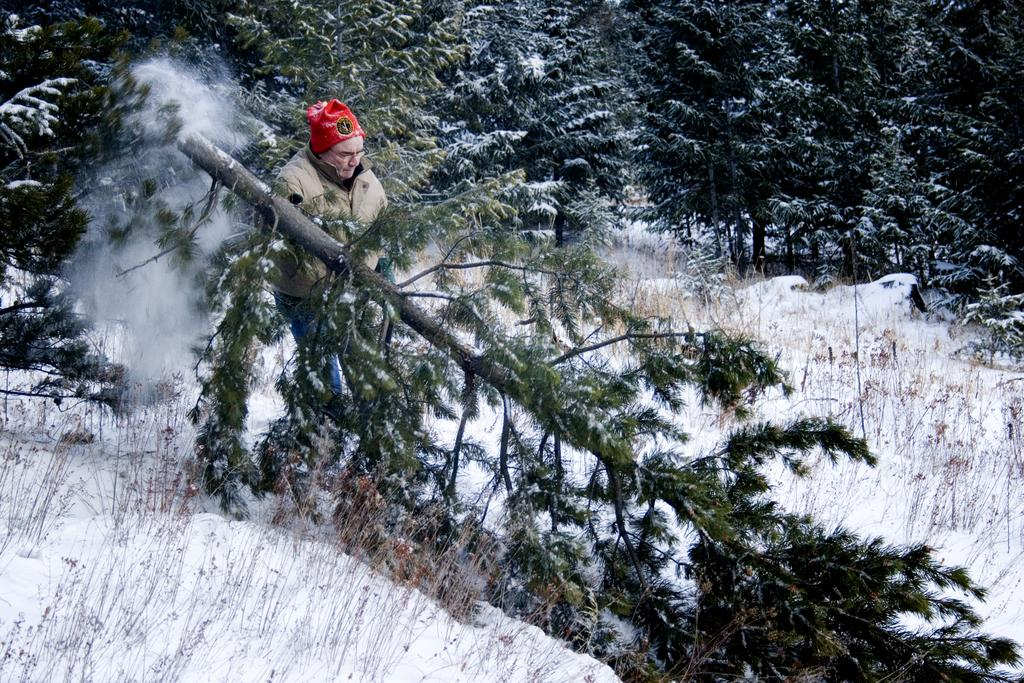Who is the main subject in the image? There is a man in the center of the image. What is the man wearing on his head? The man is wearing a cap. What is the man's posture in the image? The man is standing. What can be seen in the background of the image? There are trees in the background of the image. What is the ground covered with at the bottom of the image? There is snow at the bottom of the image. Are there any bears visible in the image? No, there are no bears present in the image. What direction is the man facing in the image? The image does not provide information about the direction the man is facing. 